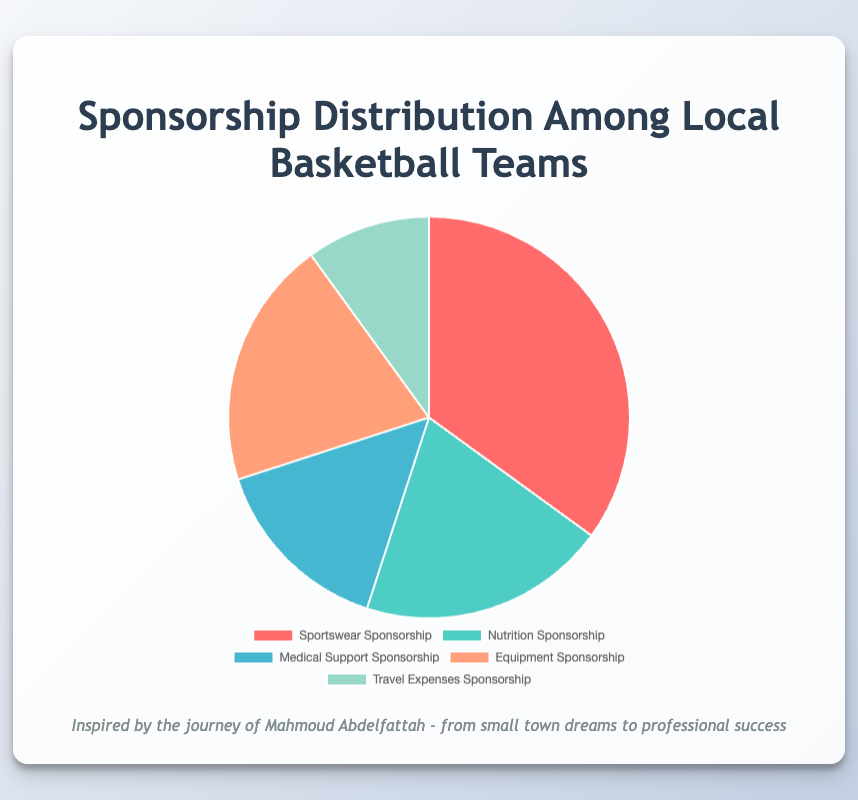Which sponsorship category has the largest share? By looking at the pie chart, the largest section will be the one with the highest percentage. The segment labeled "Sportswear Sponsorship" has the largest share at 35%.
Answer: Sportswear Sponsorship Which segments have equal sponsorship shares? From the pie chart, you can see that the segments labeled "Nutrition Sponsorship" and "Equipment Sponsorship" both have a 20% share.
Answer: Nutrition Sponsorship and Equipment Sponsorship What is the total percentage of the top two sponsorship categories combined? The top two categories are "Sportswear Sponsorship" (35%) and the two segments "Nutrition Sponsorship" and "Equipment Sponsorship" both at 20%. Adding 35% and 20%, the total is 55%.
Answer: 55% How much larger is the Sportswear Sponsorship compared to the Travel Expenses Sponsorship? The Sportswear Sponsorship is 35% and the Travel Expenses Sponsorship is 10%. Subtracting 10% from 35%, Sportswear Sponsorship is 25% larger.
Answer: 25% What is the average percentage share of the Equipment Sponsorship and Medical Support Sponsorship? Adding the values of "Equipment Sponsorship" (20%) and "Medical Support Sponsorship" (15%) gives 35%. Dividing by 2, the average is 17.5%.
Answer: 17.5% Which sponsoring companies are involved in the smallest sponsorship category? The smallest segment labeled "Travel Expenses Sponsorship" is 10%. According to the tooltip, the sponsors are American Airlines, Delta, and Marriott.
Answer: American Airlines, Delta, and Marriott What is the sum of the Nutrition Sponsorship and Medical Support Sponsorship percentages? The Nutrition Sponsorship is 20% and the Medical Support Sponsorship is 15%. Adding these values, the sum is 35%.
Answer: 35% What colors represent the Equipment Sponsorship and Nutrition Sponsorship categories? According to the pie chart, the Equipment Sponsorship category is represented by orange and the Nutrition Sponsorship category is represented by green.
Answer: Orange and Green How much lower is the Medical Support Sponsorship portion compared to the sum of Equipment and Travel Expenses Sponsorship? The Medical Support Sponsorship is 15%. The sum of Equipment (20%) and Travel Expenses Sponsorship (10%) is 30%. Subtracting 15% from 30%, it is 15% lower.
Answer: 15% 